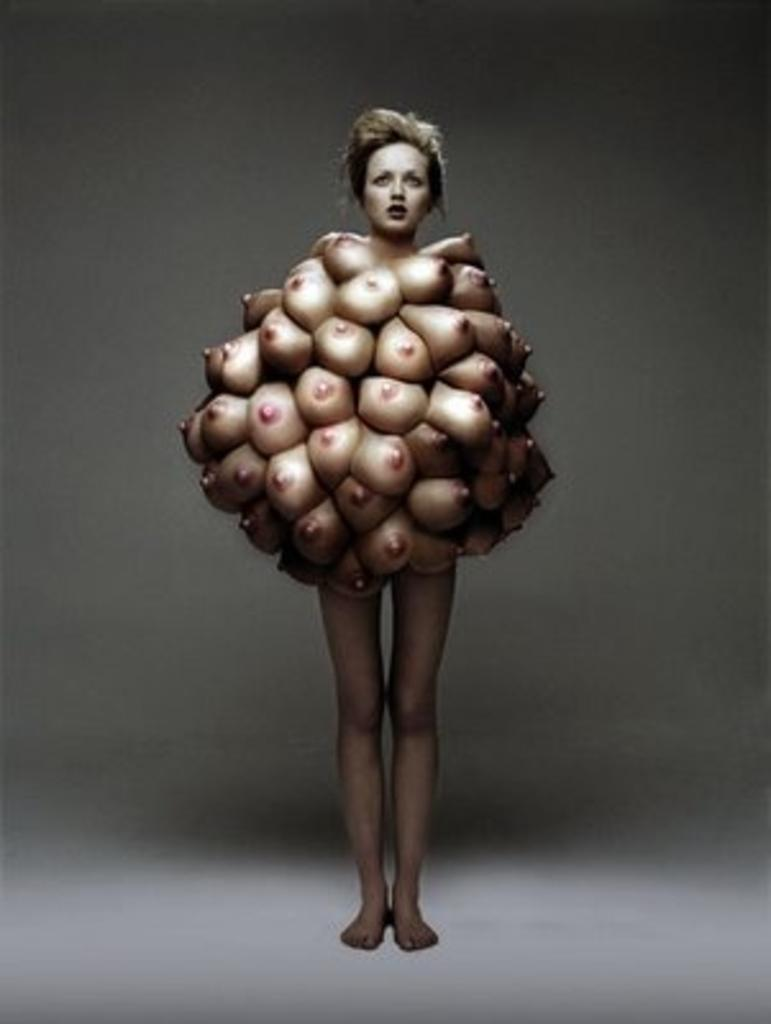What is the main subject of the image? The main subject of the image is a woman. What can be seen in the background of the image? There is a wall in the background of the image. What language is the woman speaking in the image? The image does not provide any information about the language the woman is speaking. What is on top of the woman's head in the image? There is no mention of anything on top of the woman's head in the provided facts. 